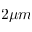<formula> <loc_0><loc_0><loc_500><loc_500>2 \mu m</formula> 